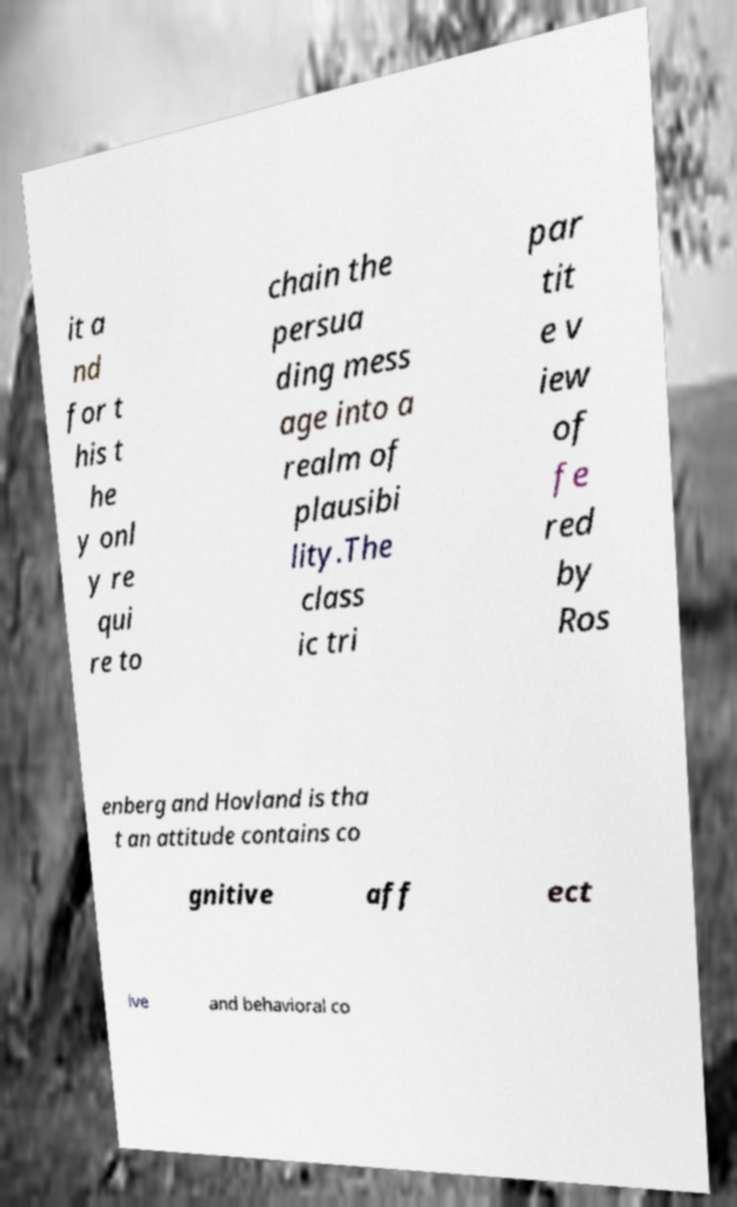Please identify and transcribe the text found in this image. it a nd for t his t he y onl y re qui re to chain the persua ding mess age into a realm of plausibi lity.The class ic tri par tit e v iew of fe red by Ros enberg and Hovland is tha t an attitude contains co gnitive aff ect ive and behavioral co 